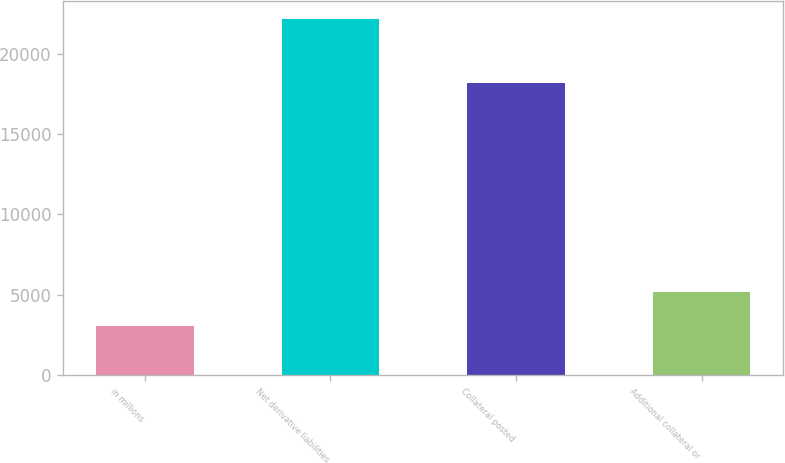<chart> <loc_0><loc_0><loc_500><loc_500><bar_chart><fcel>in millions<fcel>Net derivative liabilities<fcel>Collateral posted<fcel>Additional collateral or<nl><fcel>3037.5<fcel>22176<fcel>18178<fcel>5164<nl></chart> 